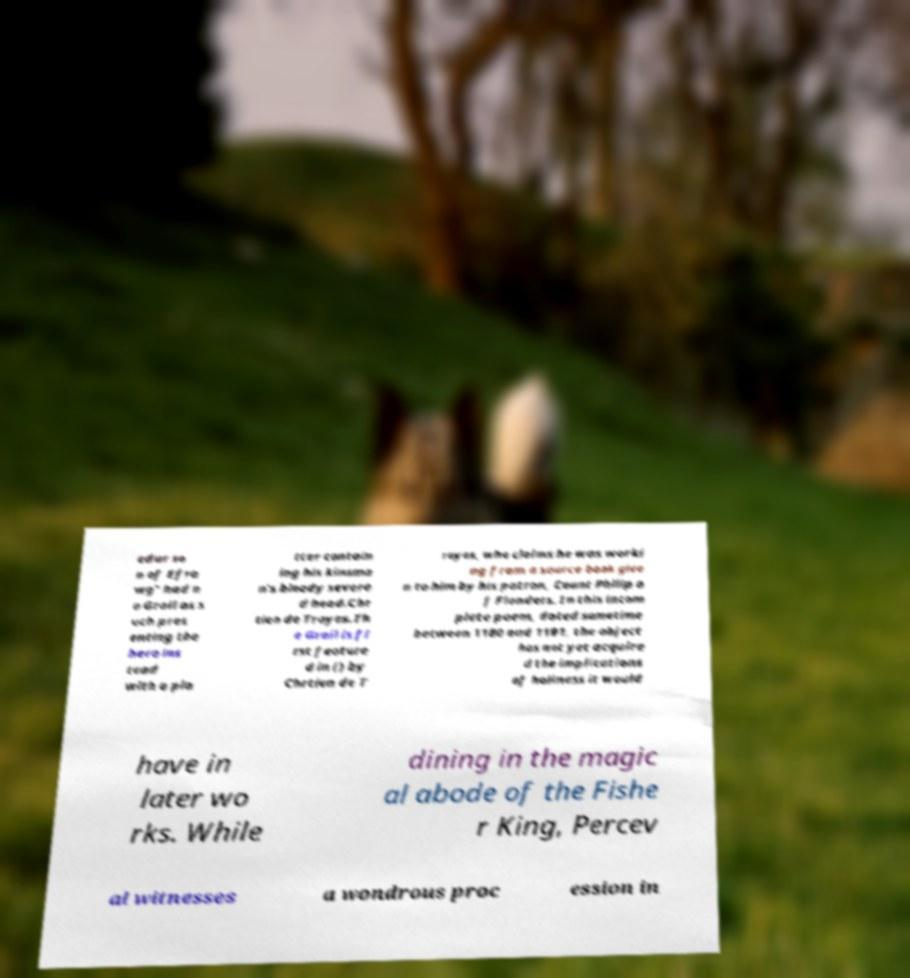Can you read and provide the text displayed in the image?This photo seems to have some interesting text. Can you extract and type it out for me? edur so n of Efra wg" had n o Grail as s uch pres enting the hero ins tead with a pla tter contain ing his kinsma n's bloody severe d head.Chr tien de Troyes.Th e Grail is fi rst feature d in () by Chrtien de T royes, who claims he was worki ng from a source book give n to him by his patron, Count Philip o f Flanders. In this incom plete poem, dated sometime between 1180 and 1191, the object has not yet acquire d the implications of holiness it would have in later wo rks. While dining in the magic al abode of the Fishe r King, Percev al witnesses a wondrous proc ession in 